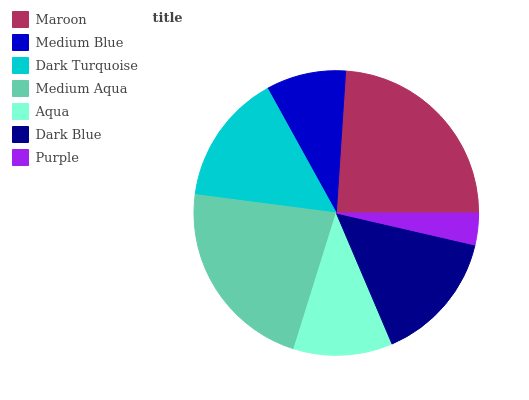Is Purple the minimum?
Answer yes or no. Yes. Is Maroon the maximum?
Answer yes or no. Yes. Is Medium Blue the minimum?
Answer yes or no. No. Is Medium Blue the maximum?
Answer yes or no. No. Is Maroon greater than Medium Blue?
Answer yes or no. Yes. Is Medium Blue less than Maroon?
Answer yes or no. Yes. Is Medium Blue greater than Maroon?
Answer yes or no. No. Is Maroon less than Medium Blue?
Answer yes or no. No. Is Dark Turquoise the high median?
Answer yes or no. Yes. Is Dark Turquoise the low median?
Answer yes or no. Yes. Is Medium Blue the high median?
Answer yes or no. No. Is Purple the low median?
Answer yes or no. No. 